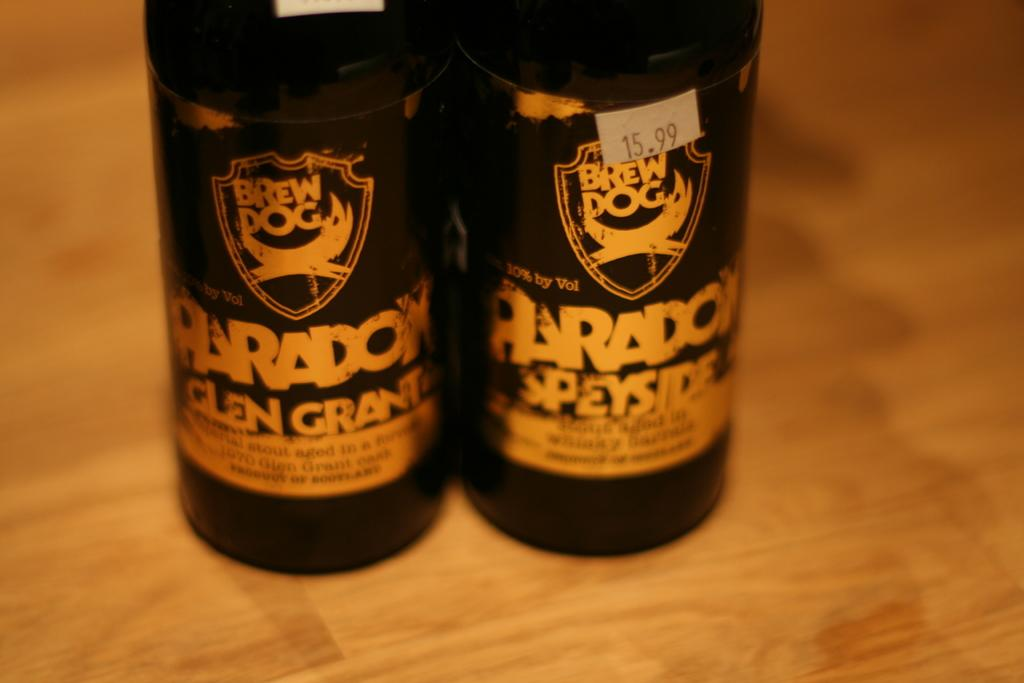<image>
Present a compact description of the photo's key features. two bottles of Brew Dog Paradox for 15.99 